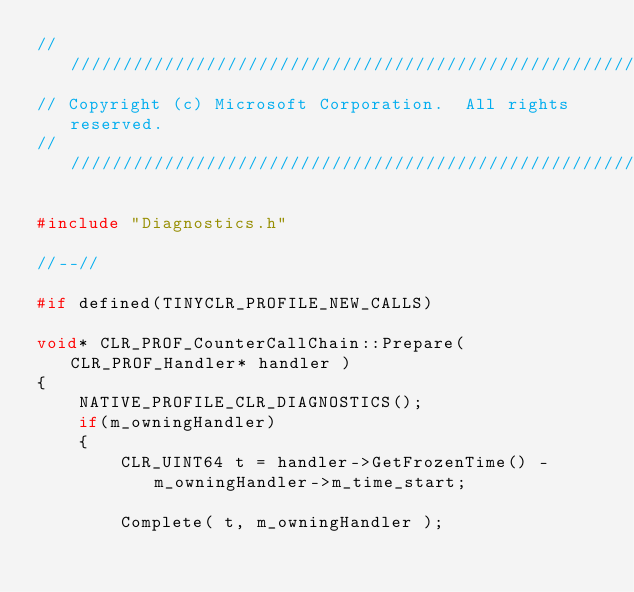<code> <loc_0><loc_0><loc_500><loc_500><_C++_>////////////////////////////////////////////////////////////////////////////////////////////////////////////////////////////////////////////////////////////////////////////////////////////////////////
// Copyright (c) Microsoft Corporation.  All rights reserved.
////////////////////////////////////////////////////////////////////////////////////////////////////////////////////////////////////////////////////////////////////////////////////////////////////////

#include "Diagnostics.h"

//--//

#if defined(TINYCLR_PROFILE_NEW_CALLS)

void* CLR_PROF_CounterCallChain::Prepare( CLR_PROF_Handler* handler )
{
    NATIVE_PROFILE_CLR_DIAGNOSTICS();
    if(m_owningHandler)
    {
        CLR_UINT64 t = handler->GetFrozenTime() - m_owningHandler->m_time_start;

        Complete( t, m_owningHandler );
</code> 